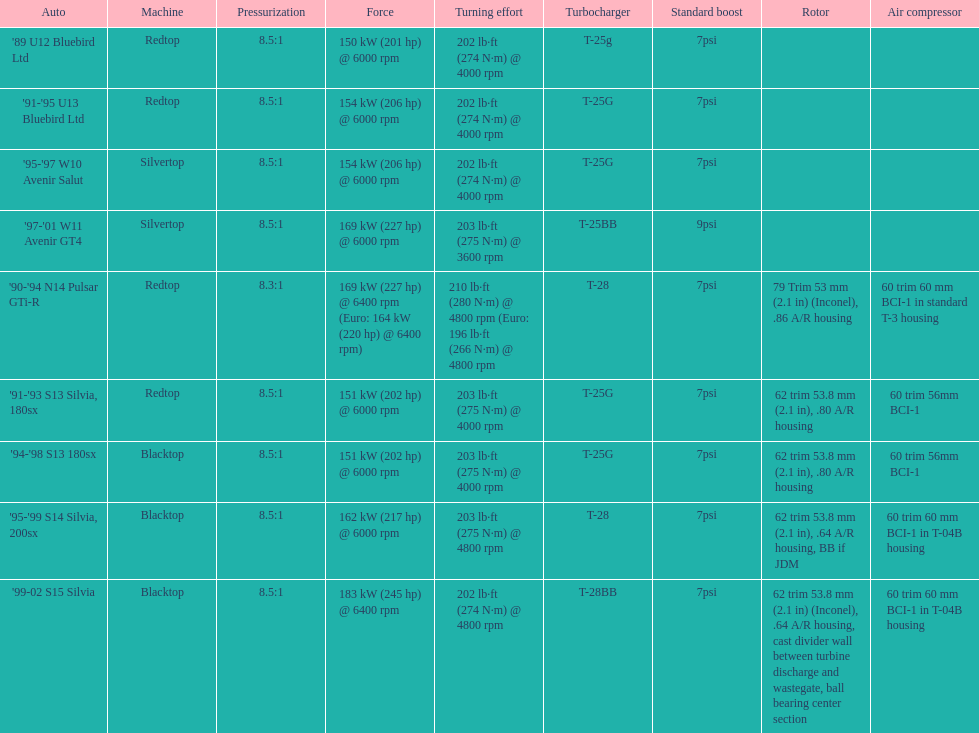Can you give me this table as a dict? {'header': ['Auto', 'Machine', 'Pressurization', 'Force', 'Turning effort', 'Turbocharger', 'Standard boost', 'Rotor', 'Air compressor'], 'rows': [["'89 U12 Bluebird Ltd", 'Redtop', '8.5:1', '150\xa0kW (201\xa0hp) @ 6000 rpm', '202\xa0lb·ft (274\xa0N·m) @ 4000 rpm', 'T-25g', '7psi', '', ''], ["'91-'95 U13 Bluebird Ltd", 'Redtop', '8.5:1', '154\xa0kW (206\xa0hp) @ 6000 rpm', '202\xa0lb·ft (274\xa0N·m) @ 4000 rpm', 'T-25G', '7psi', '', ''], ["'95-'97 W10 Avenir Salut", 'Silvertop', '8.5:1', '154\xa0kW (206\xa0hp) @ 6000 rpm', '202\xa0lb·ft (274\xa0N·m) @ 4000 rpm', 'T-25G', '7psi', '', ''], ["'97-'01 W11 Avenir GT4", 'Silvertop', '8.5:1', '169\xa0kW (227\xa0hp) @ 6000 rpm', '203\xa0lb·ft (275\xa0N·m) @ 3600 rpm', 'T-25BB', '9psi', '', ''], ["'90-'94 N14 Pulsar GTi-R", 'Redtop', '8.3:1', '169\xa0kW (227\xa0hp) @ 6400 rpm (Euro: 164\xa0kW (220\xa0hp) @ 6400 rpm)', '210\xa0lb·ft (280\xa0N·m) @ 4800 rpm (Euro: 196\xa0lb·ft (266\xa0N·m) @ 4800 rpm', 'T-28', '7psi', '79 Trim 53\xa0mm (2.1\xa0in) (Inconel), .86 A/R housing', '60 trim 60\xa0mm BCI-1 in standard T-3 housing'], ["'91-'93 S13 Silvia, 180sx", 'Redtop', '8.5:1', '151\xa0kW (202\xa0hp) @ 6000 rpm', '203\xa0lb·ft (275\xa0N·m) @ 4000 rpm', 'T-25G', '7psi', '62 trim 53.8\xa0mm (2.1\xa0in), .80 A/R housing', '60 trim 56mm BCI-1'], ["'94-'98 S13 180sx", 'Blacktop', '8.5:1', '151\xa0kW (202\xa0hp) @ 6000 rpm', '203\xa0lb·ft (275\xa0N·m) @ 4000 rpm', 'T-25G', '7psi', '62 trim 53.8\xa0mm (2.1\xa0in), .80 A/R housing', '60 trim 56mm BCI-1'], ["'95-'99 S14 Silvia, 200sx", 'Blacktop', '8.5:1', '162\xa0kW (217\xa0hp) @ 6000 rpm', '203\xa0lb·ft (275\xa0N·m) @ 4800 rpm', 'T-28', '7psi', '62 trim 53.8\xa0mm (2.1\xa0in), .64 A/R housing, BB if JDM', '60 trim 60\xa0mm BCI-1 in T-04B housing'], ["'99-02 S15 Silvia", 'Blacktop', '8.5:1', '183\xa0kW (245\xa0hp) @ 6400 rpm', '202\xa0lb·ft (274\xa0N·m) @ 4800 rpm', 'T-28BB', '7psi', '62 trim 53.8\xa0mm (2.1\xa0in) (Inconel), .64 A/R housing, cast divider wall between turbine discharge and wastegate, ball bearing center section', '60 trim 60\xa0mm BCI-1 in T-04B housing']]} What is his/her compression for the 90-94 n14 pulsar gti-r? 8.3:1. 